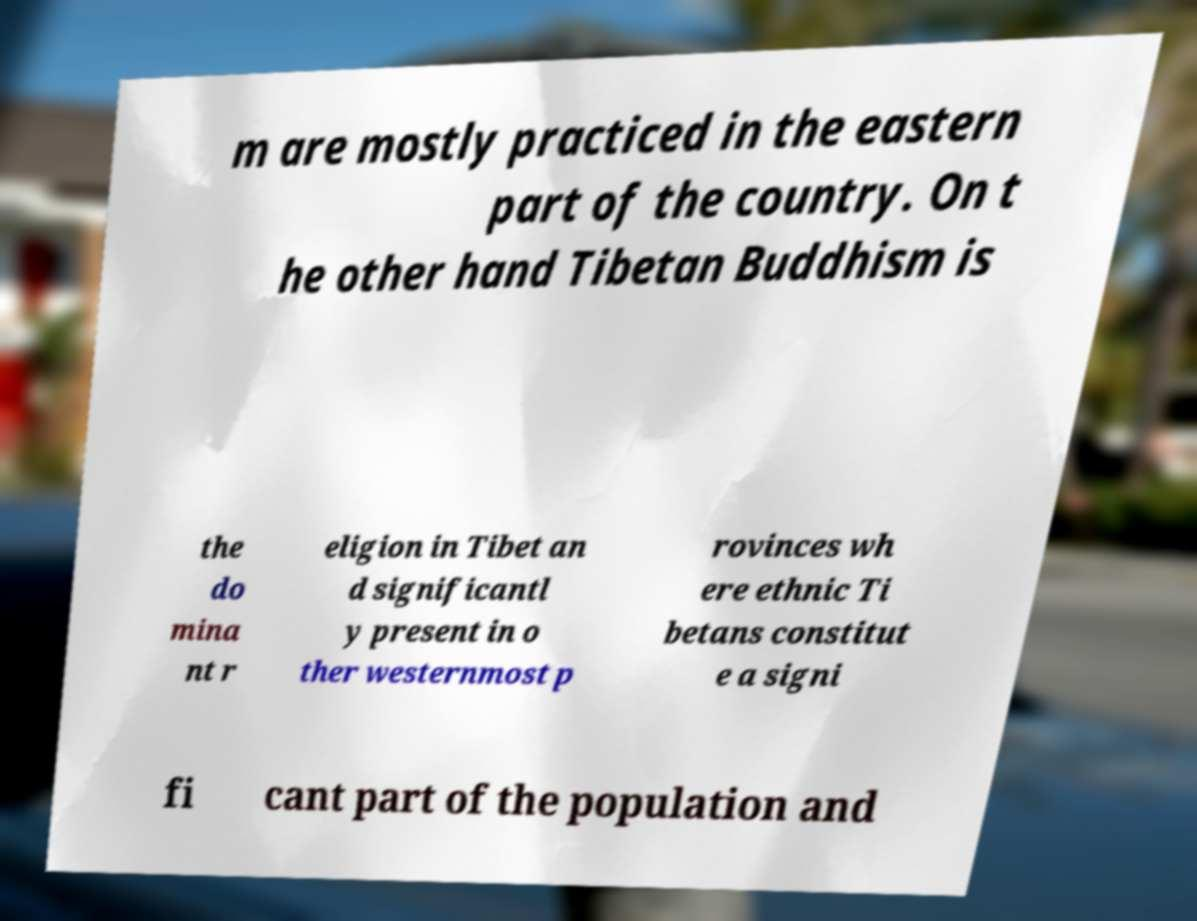I need the written content from this picture converted into text. Can you do that? m are mostly practiced in the eastern part of the country. On t he other hand Tibetan Buddhism is the do mina nt r eligion in Tibet an d significantl y present in o ther westernmost p rovinces wh ere ethnic Ti betans constitut e a signi fi cant part of the population and 